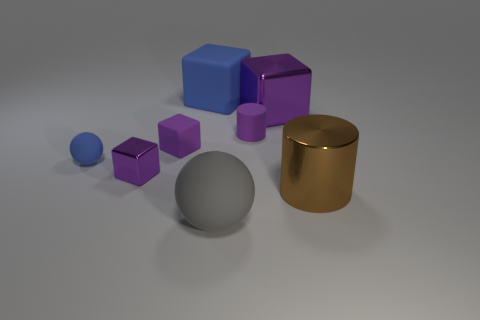Could you infer anything about the lighting of the scene based on the shadows? Observing the shadows in the image, it seems there's a single light source positioned above the objects, slightly off to the right. The shadows are soft-edged, indicating the light source is not extremely close to the objects but still within a range that produces discernible shadows. This suggests indoor lighting, perhaps from a ceiling fixture that diffuses light softly over the scene. 